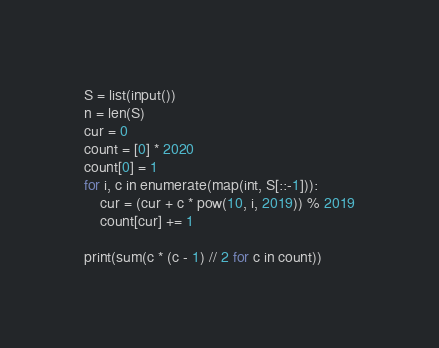<code> <loc_0><loc_0><loc_500><loc_500><_Python_>S = list(input())
n = len(S)
cur = 0
count = [0] * 2020
count[0] = 1
for i, c in enumerate(map(int, S[::-1])):
    cur = (cur + c * pow(10, i, 2019)) % 2019
    count[cur] += 1
    
print(sum(c * (c - 1) // 2 for c in count))</code> 